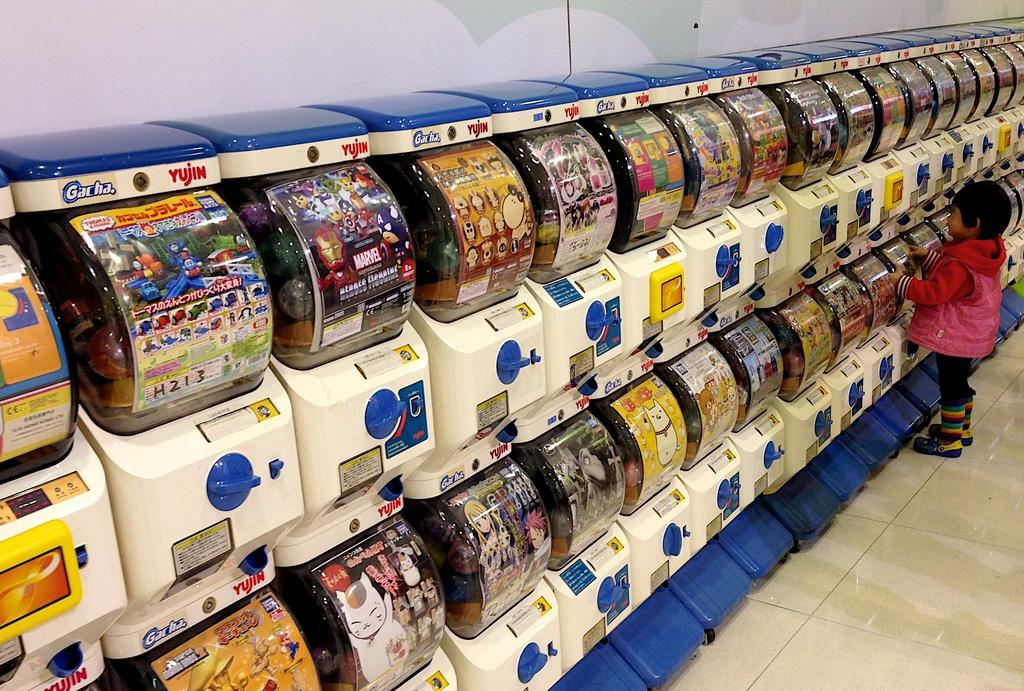<image>
Give a short and clear explanation of the subsequent image. A small child is standing in front of vending machines that say Gacha Yujin. 